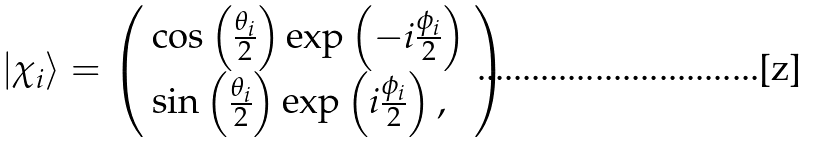Convert formula to latex. <formula><loc_0><loc_0><loc_500><loc_500>| \chi _ { i } \rangle = \left ( \begin{array} { l } \cos \left ( \frac { \theta _ { i } } { 2 } \right ) \exp \left ( - i \frac { \phi _ { i } } { 2 } \right ) \\ \sin \left ( \frac { \theta _ { i } } { 2 } \right ) \exp \left ( i \frac { \phi _ { i } } { 2 } \right ) , \end{array} \right )</formula> 